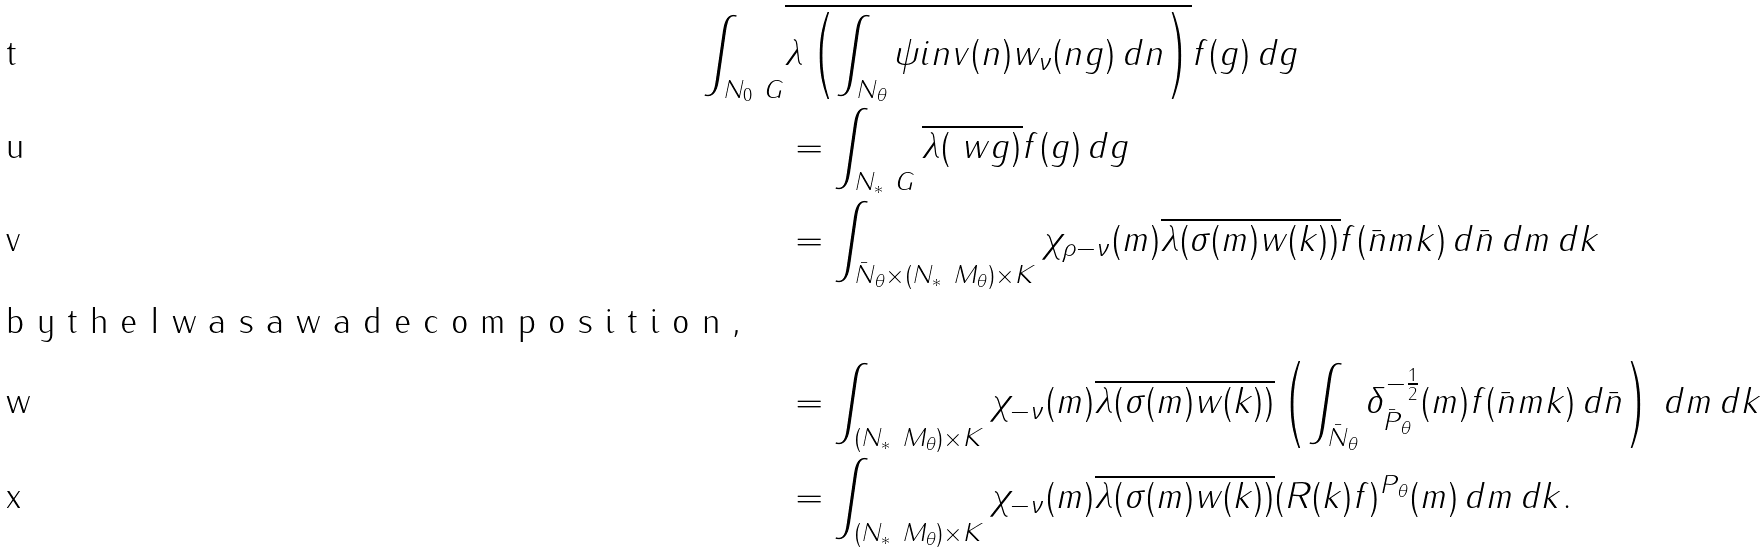<formula> <loc_0><loc_0><loc_500><loc_500>\int _ { N _ { 0 } \ G } & \overline { \lambda \left ( \int _ { N _ { \theta } } \psi i n v ( n ) w _ { \nu } ( n g ) \, d n \right ) } f ( g ) \, d g \\ & = \int _ { N _ { * } \ G } \overline { \lambda ( \ w { g } ) } f ( g ) \, d g \\ & = \int _ { \bar { N } _ { \theta } \times ( N _ { * } \ M _ { \theta } ) \times K } \chi _ { \rho - \nu } ( m ) \overline { \lambda ( \sigma ( m ) w ( k ) ) } f ( \bar { n } m k ) \, d \bar { n } \, d m \, d k \\ \intertext { b y t h e I w a s a w a d e c o m p o s i t i o n , } & = \int _ { ( N _ { * } \ M _ { \theta } ) \times K } \chi _ { - \nu } ( m ) \overline { \lambda ( \sigma ( m ) w ( k ) ) } \left ( \int _ { \bar { N } _ { \theta } } \delta ^ { - \frac { 1 } { 2 } } _ { \bar { P } _ { \theta } } ( m ) f ( \bar { n } m k ) \, d \bar { n } \right ) \, d m \, d k \\ & = \int _ { ( N _ { * } \ M _ { \theta } ) \times K } \chi _ { - \nu } ( m ) \overline { \lambda ( \sigma ( m ) w ( k ) ) } ( R ( k ) f ) ^ { P _ { \theta } } ( m ) \, d m \, d k .</formula> 